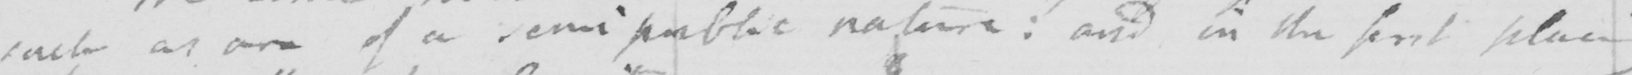Can you read and transcribe this handwriting? of such as are of a semi public nature :  and in the first place 